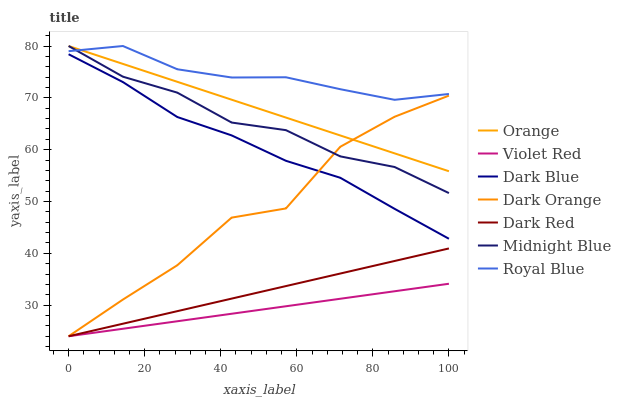Does Midnight Blue have the minimum area under the curve?
Answer yes or no. No. Does Midnight Blue have the maximum area under the curve?
Answer yes or no. No. Is Midnight Blue the smoothest?
Answer yes or no. No. Is Midnight Blue the roughest?
Answer yes or no. No. Does Midnight Blue have the lowest value?
Answer yes or no. No. Does Violet Red have the highest value?
Answer yes or no. No. Is Violet Red less than Dark Blue?
Answer yes or no. Yes. Is Royal Blue greater than Dark Orange?
Answer yes or no. Yes. Does Violet Red intersect Dark Blue?
Answer yes or no. No. 